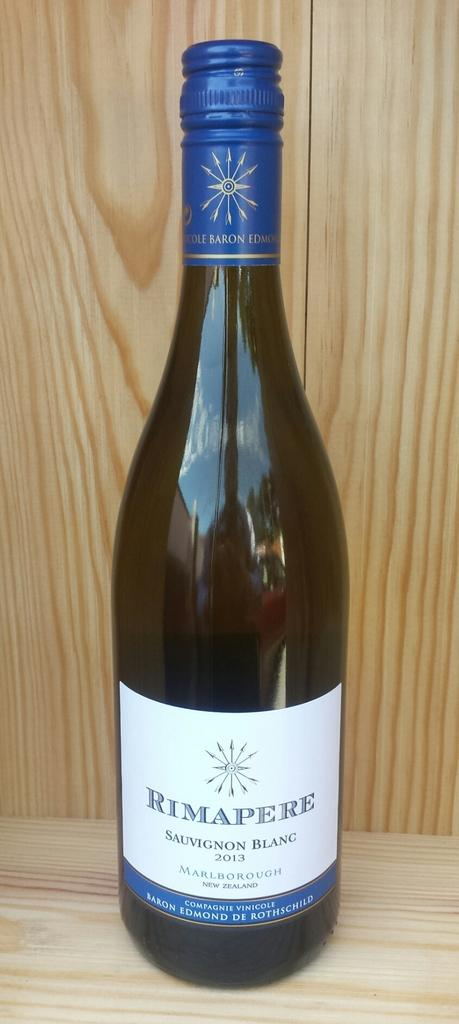<image>
Write a terse but informative summary of the picture. a bottle of Rimapere Sauvignon Blanc wine in front of a wood wall 